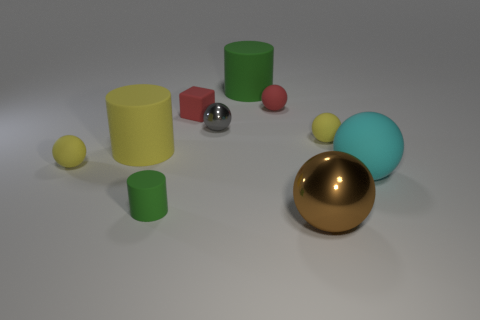Subtract all gray balls. How many balls are left? 5 Subtract all small gray metal balls. How many balls are left? 5 Subtract all green balls. Subtract all brown blocks. How many balls are left? 6 Subtract all spheres. How many objects are left? 4 Add 9 big green cylinders. How many big green cylinders are left? 10 Add 5 cylinders. How many cylinders exist? 8 Subtract 0 purple balls. How many objects are left? 10 Subtract all gray balls. Subtract all rubber cylinders. How many objects are left? 6 